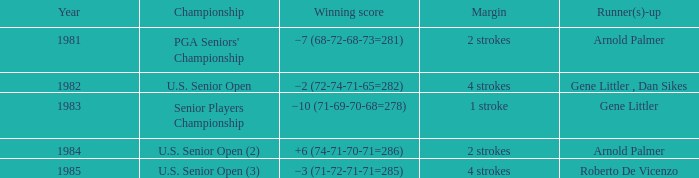What contest was in 1985? U.S. Senior Open (3). 